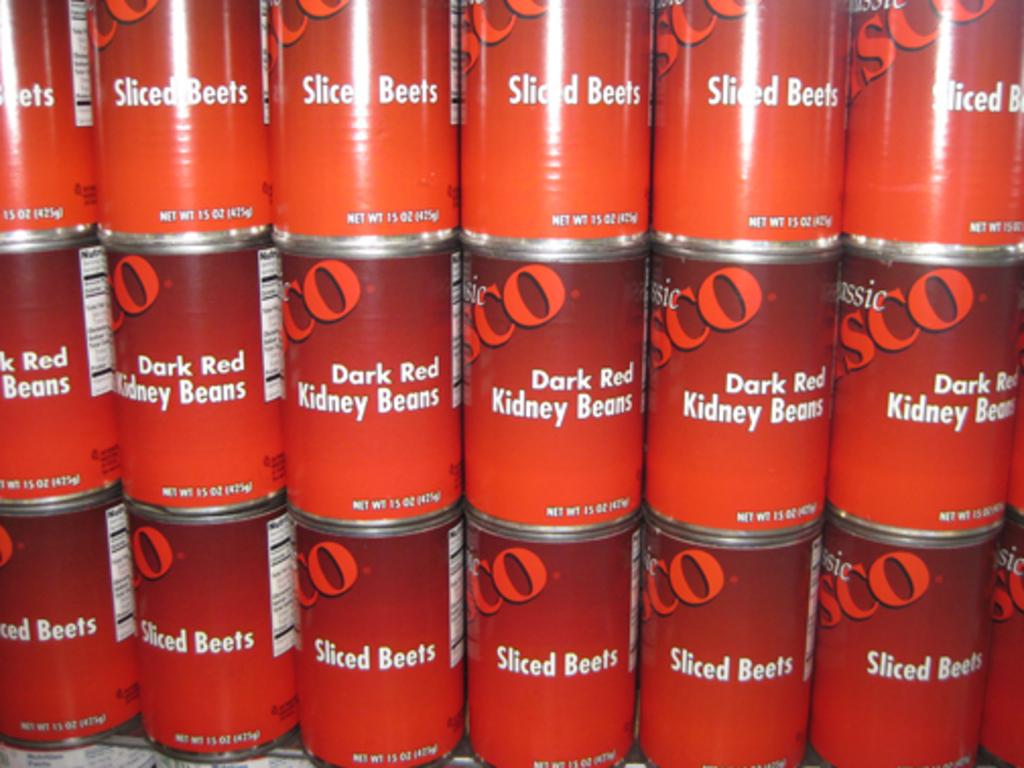What vegetable is on the bottom row?
Ensure brevity in your answer.  Sliced beets. 